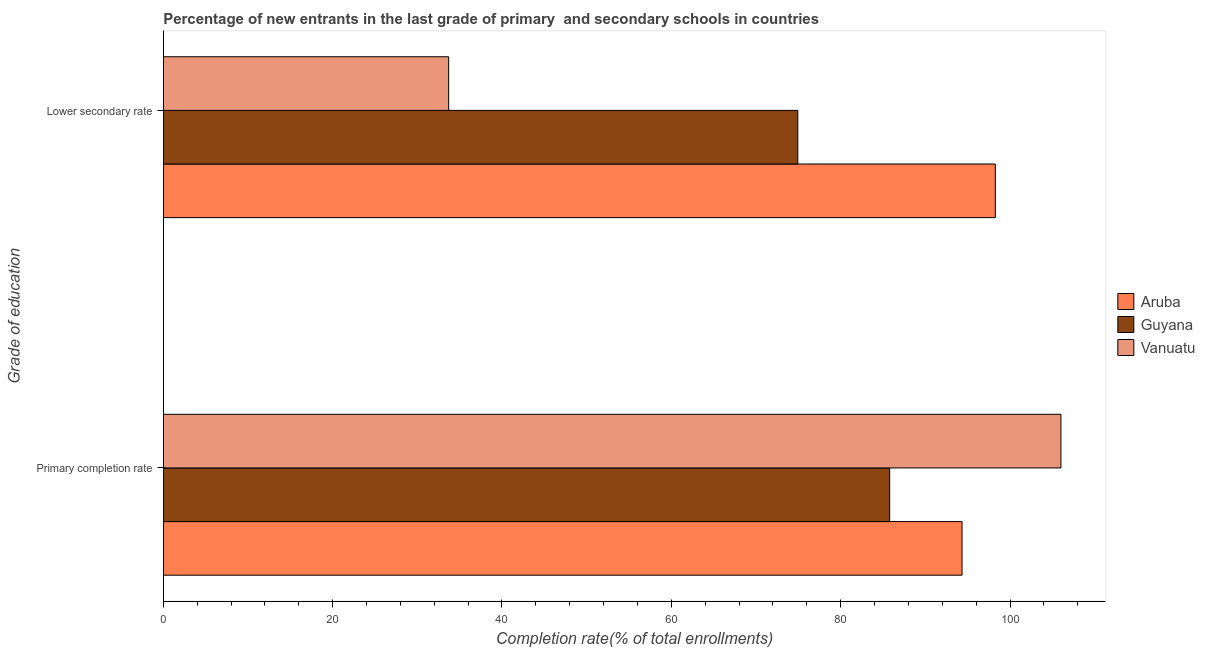How many groups of bars are there?
Offer a very short reply. 2. Are the number of bars on each tick of the Y-axis equal?
Give a very brief answer. Yes. How many bars are there on the 2nd tick from the bottom?
Provide a short and direct response. 3. What is the label of the 2nd group of bars from the top?
Offer a terse response. Primary completion rate. What is the completion rate in primary schools in Aruba?
Provide a succinct answer. 94.34. Across all countries, what is the maximum completion rate in primary schools?
Your response must be concise. 106.02. Across all countries, what is the minimum completion rate in secondary schools?
Provide a succinct answer. 33.71. In which country was the completion rate in secondary schools maximum?
Your answer should be very brief. Aruba. In which country was the completion rate in primary schools minimum?
Provide a succinct answer. Guyana. What is the total completion rate in primary schools in the graph?
Provide a succinct answer. 286.14. What is the difference between the completion rate in secondary schools in Vanuatu and that in Guyana?
Provide a succinct answer. -41.23. What is the difference between the completion rate in secondary schools in Aruba and the completion rate in primary schools in Guyana?
Ensure brevity in your answer.  12.48. What is the average completion rate in primary schools per country?
Give a very brief answer. 95.38. What is the difference between the completion rate in primary schools and completion rate in secondary schools in Guyana?
Keep it short and to the point. 10.85. In how many countries, is the completion rate in secondary schools greater than 88 %?
Your response must be concise. 1. What is the ratio of the completion rate in primary schools in Guyana to that in Aruba?
Ensure brevity in your answer.  0.91. Is the completion rate in secondary schools in Aruba less than that in Guyana?
Give a very brief answer. No. What does the 2nd bar from the top in Lower secondary rate represents?
Your answer should be compact. Guyana. What does the 2nd bar from the bottom in Lower secondary rate represents?
Keep it short and to the point. Guyana. How many countries are there in the graph?
Provide a short and direct response. 3. Does the graph contain any zero values?
Your answer should be compact. No. Where does the legend appear in the graph?
Your answer should be very brief. Center right. What is the title of the graph?
Give a very brief answer. Percentage of new entrants in the last grade of primary  and secondary schools in countries. What is the label or title of the X-axis?
Your answer should be compact. Completion rate(% of total enrollments). What is the label or title of the Y-axis?
Make the answer very short. Grade of education. What is the Completion rate(% of total enrollments) of Aruba in Primary completion rate?
Your answer should be very brief. 94.34. What is the Completion rate(% of total enrollments) in Guyana in Primary completion rate?
Offer a terse response. 85.79. What is the Completion rate(% of total enrollments) of Vanuatu in Primary completion rate?
Offer a very short reply. 106.02. What is the Completion rate(% of total enrollments) in Aruba in Lower secondary rate?
Keep it short and to the point. 98.27. What is the Completion rate(% of total enrollments) of Guyana in Lower secondary rate?
Your answer should be compact. 74.94. What is the Completion rate(% of total enrollments) in Vanuatu in Lower secondary rate?
Your answer should be compact. 33.71. Across all Grade of education, what is the maximum Completion rate(% of total enrollments) of Aruba?
Give a very brief answer. 98.27. Across all Grade of education, what is the maximum Completion rate(% of total enrollments) of Guyana?
Ensure brevity in your answer.  85.79. Across all Grade of education, what is the maximum Completion rate(% of total enrollments) of Vanuatu?
Give a very brief answer. 106.02. Across all Grade of education, what is the minimum Completion rate(% of total enrollments) of Aruba?
Offer a very short reply. 94.34. Across all Grade of education, what is the minimum Completion rate(% of total enrollments) in Guyana?
Provide a succinct answer. 74.94. Across all Grade of education, what is the minimum Completion rate(% of total enrollments) in Vanuatu?
Make the answer very short. 33.71. What is the total Completion rate(% of total enrollments) of Aruba in the graph?
Your answer should be very brief. 192.6. What is the total Completion rate(% of total enrollments) of Guyana in the graph?
Provide a succinct answer. 160.73. What is the total Completion rate(% of total enrollments) in Vanuatu in the graph?
Your answer should be very brief. 139.72. What is the difference between the Completion rate(% of total enrollments) of Aruba in Primary completion rate and that in Lower secondary rate?
Make the answer very short. -3.93. What is the difference between the Completion rate(% of total enrollments) in Guyana in Primary completion rate and that in Lower secondary rate?
Make the answer very short. 10.85. What is the difference between the Completion rate(% of total enrollments) of Vanuatu in Primary completion rate and that in Lower secondary rate?
Provide a short and direct response. 72.31. What is the difference between the Completion rate(% of total enrollments) in Aruba in Primary completion rate and the Completion rate(% of total enrollments) in Guyana in Lower secondary rate?
Keep it short and to the point. 19.39. What is the difference between the Completion rate(% of total enrollments) in Aruba in Primary completion rate and the Completion rate(% of total enrollments) in Vanuatu in Lower secondary rate?
Your answer should be very brief. 60.63. What is the difference between the Completion rate(% of total enrollments) of Guyana in Primary completion rate and the Completion rate(% of total enrollments) of Vanuatu in Lower secondary rate?
Make the answer very short. 52.08. What is the average Completion rate(% of total enrollments) of Aruba per Grade of education?
Your answer should be very brief. 96.3. What is the average Completion rate(% of total enrollments) in Guyana per Grade of education?
Make the answer very short. 80.36. What is the average Completion rate(% of total enrollments) in Vanuatu per Grade of education?
Provide a succinct answer. 69.86. What is the difference between the Completion rate(% of total enrollments) of Aruba and Completion rate(% of total enrollments) of Guyana in Primary completion rate?
Your response must be concise. 8.55. What is the difference between the Completion rate(% of total enrollments) of Aruba and Completion rate(% of total enrollments) of Vanuatu in Primary completion rate?
Your answer should be compact. -11.68. What is the difference between the Completion rate(% of total enrollments) of Guyana and Completion rate(% of total enrollments) of Vanuatu in Primary completion rate?
Keep it short and to the point. -20.23. What is the difference between the Completion rate(% of total enrollments) in Aruba and Completion rate(% of total enrollments) in Guyana in Lower secondary rate?
Ensure brevity in your answer.  23.33. What is the difference between the Completion rate(% of total enrollments) of Aruba and Completion rate(% of total enrollments) of Vanuatu in Lower secondary rate?
Provide a succinct answer. 64.56. What is the difference between the Completion rate(% of total enrollments) of Guyana and Completion rate(% of total enrollments) of Vanuatu in Lower secondary rate?
Your answer should be compact. 41.23. What is the ratio of the Completion rate(% of total enrollments) of Aruba in Primary completion rate to that in Lower secondary rate?
Provide a short and direct response. 0.96. What is the ratio of the Completion rate(% of total enrollments) of Guyana in Primary completion rate to that in Lower secondary rate?
Ensure brevity in your answer.  1.14. What is the ratio of the Completion rate(% of total enrollments) of Vanuatu in Primary completion rate to that in Lower secondary rate?
Your response must be concise. 3.15. What is the difference between the highest and the second highest Completion rate(% of total enrollments) of Aruba?
Provide a succinct answer. 3.93. What is the difference between the highest and the second highest Completion rate(% of total enrollments) of Guyana?
Your answer should be very brief. 10.85. What is the difference between the highest and the second highest Completion rate(% of total enrollments) in Vanuatu?
Give a very brief answer. 72.31. What is the difference between the highest and the lowest Completion rate(% of total enrollments) of Aruba?
Your response must be concise. 3.93. What is the difference between the highest and the lowest Completion rate(% of total enrollments) of Guyana?
Your answer should be very brief. 10.85. What is the difference between the highest and the lowest Completion rate(% of total enrollments) of Vanuatu?
Give a very brief answer. 72.31. 